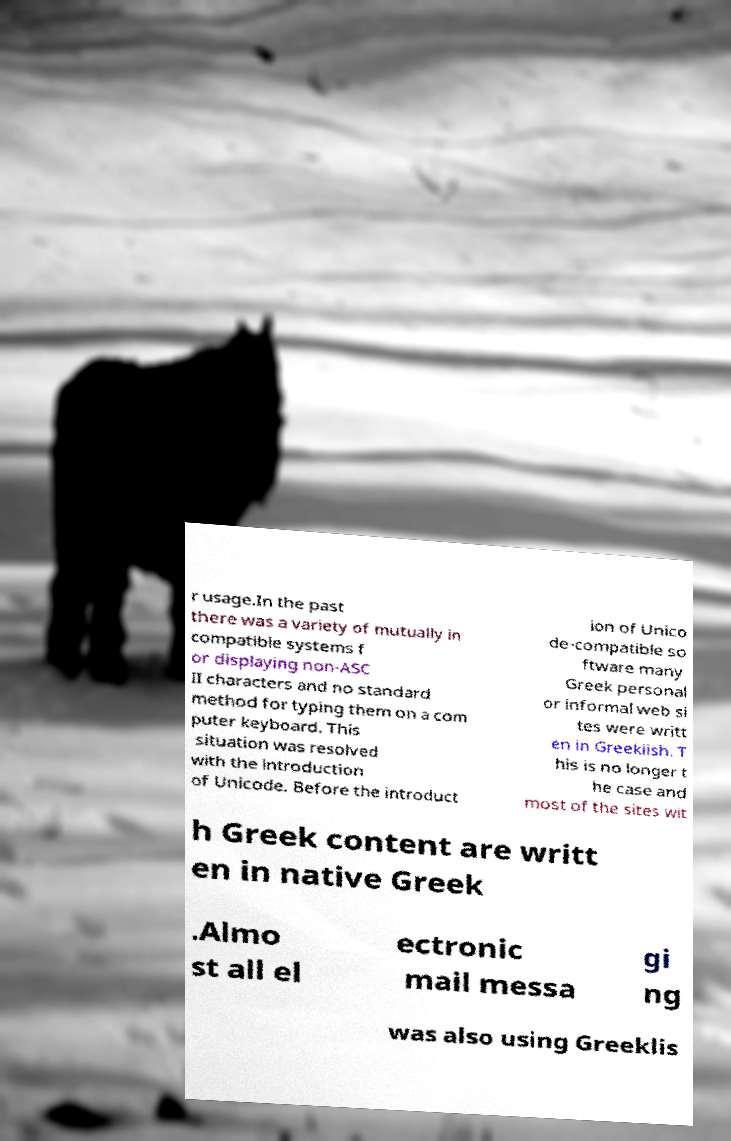What messages or text are displayed in this image? I need them in a readable, typed format. r usage.In the past there was a variety of mutually in compatible systems f or displaying non-ASC II characters and no standard method for typing them on a com puter keyboard. This situation was resolved with the introduction of Unicode. Before the introduct ion of Unico de-compatible so ftware many Greek personal or informal web si tes were writt en in Greeklish. T his is no longer t he case and most of the sites wit h Greek content are writt en in native Greek .Almo st all el ectronic mail messa gi ng was also using Greeklis 